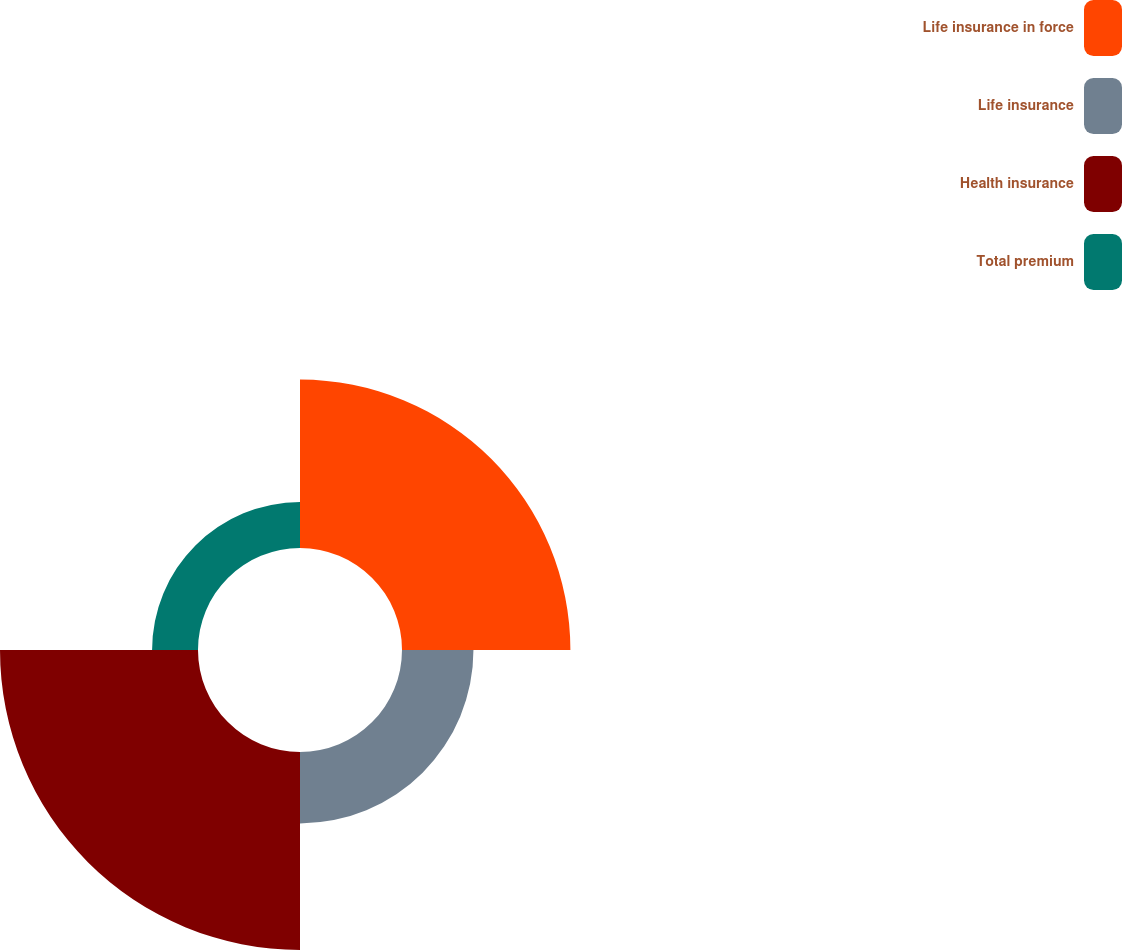<chart> <loc_0><loc_0><loc_500><loc_500><pie_chart><fcel>Life insurance in force<fcel>Life insurance<fcel>Health insurance<fcel>Total premium<nl><fcel>34.81%<fcel>14.77%<fcel>40.93%<fcel>9.49%<nl></chart> 